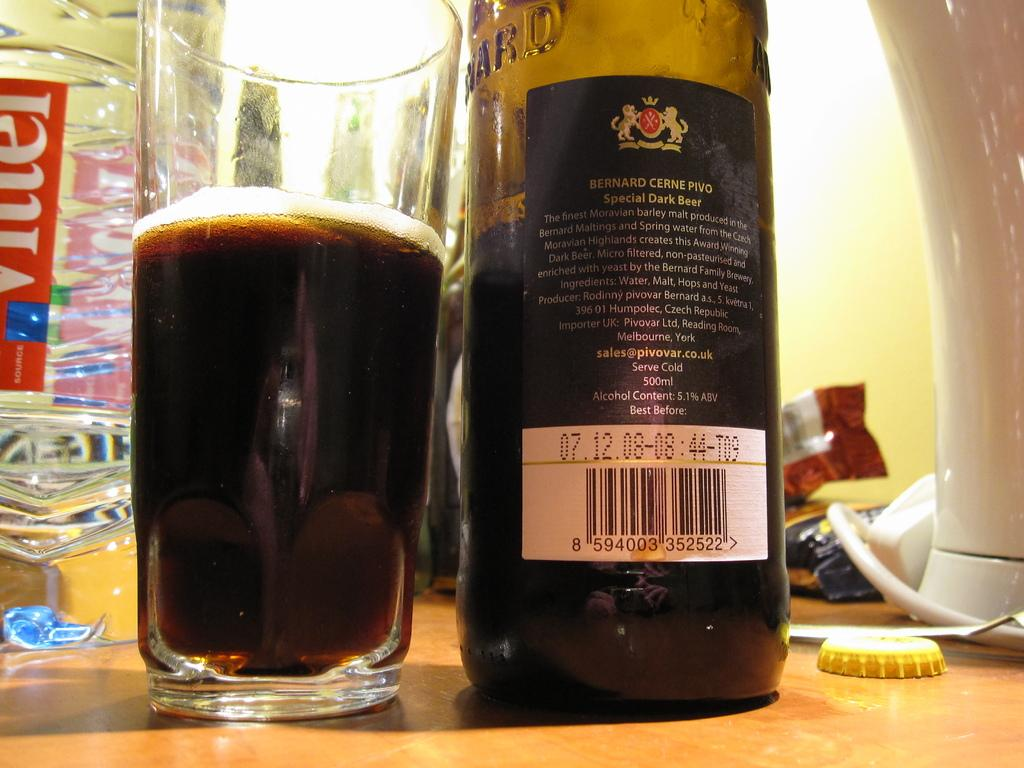<image>
Describe the image concisely. A cup full of beer and a bottle of beer are next to each other. 